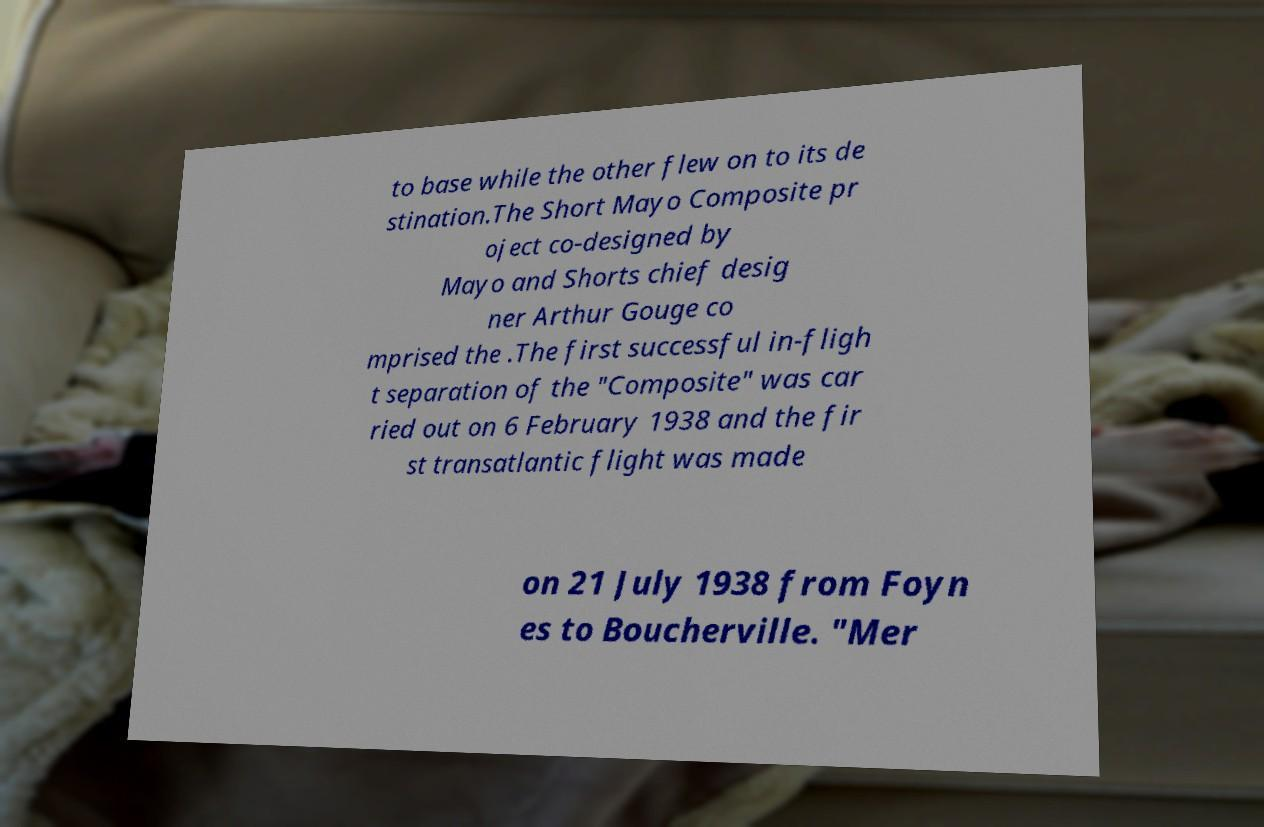There's text embedded in this image that I need extracted. Can you transcribe it verbatim? to base while the other flew on to its de stination.The Short Mayo Composite pr oject co-designed by Mayo and Shorts chief desig ner Arthur Gouge co mprised the .The first successful in-fligh t separation of the "Composite" was car ried out on 6 February 1938 and the fir st transatlantic flight was made on 21 July 1938 from Foyn es to Boucherville. "Mer 